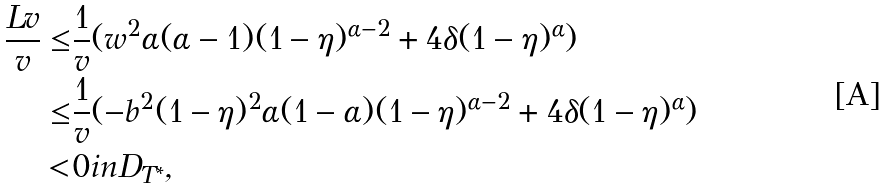<formula> <loc_0><loc_0><loc_500><loc_500>\frac { L v } { v } \leq & \frac { 1 } { v } ( w ^ { 2 } \alpha ( \alpha - 1 ) ( 1 - \eta ) ^ { \alpha - 2 } + 4 \delta ( 1 - \eta ) ^ { \alpha } ) \\ \leq & \frac { 1 } { v } ( - b ^ { 2 } ( 1 - \eta ) ^ { 2 } \alpha ( 1 - \alpha ) ( 1 - \eta ) ^ { \alpha - 2 } + 4 \delta ( 1 - \eta ) ^ { \alpha } ) \\ < & 0 i n D _ { T ^ { * } } ,</formula> 